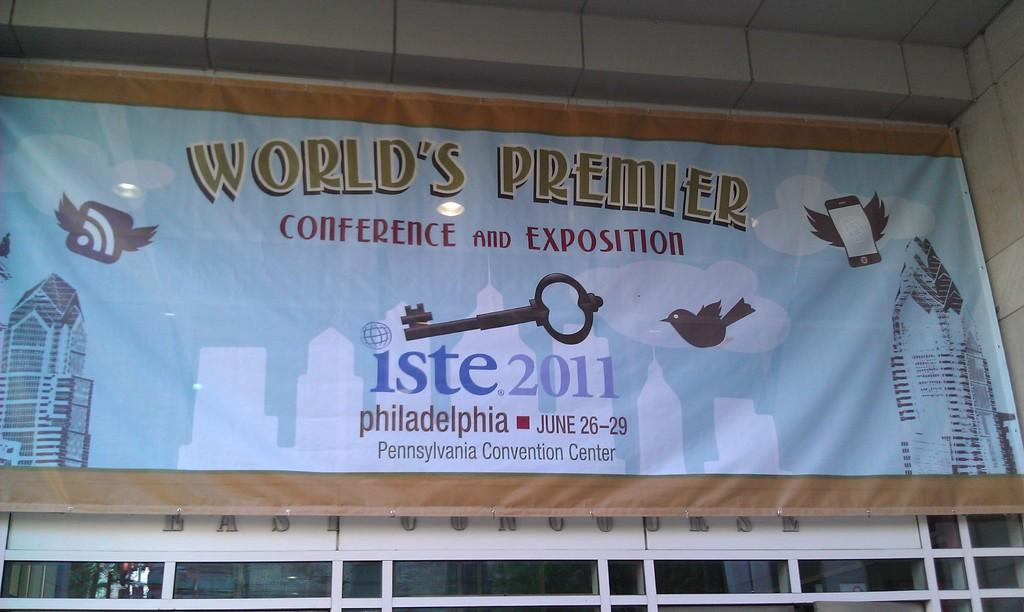<image>
Summarize the visual content of the image. a banner for the World's premier conference and exposition 